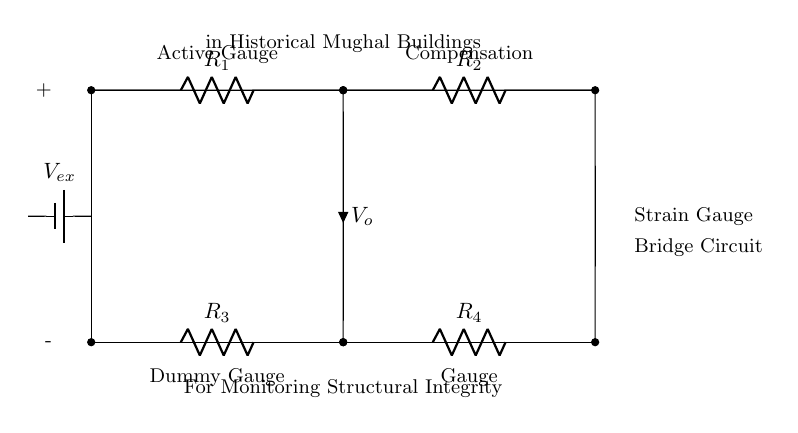What are the resistors labeled as in this circuit? The resistors in this circuit are labeled as R1, R2, R3, and R4, indicating the different positions within the bridge configuration.
Answer: R1, R2, R3, R4 What type of gauges are indicated in the circuit? The circuit includes one active gauge, one dummy gauge, and one compensation gauge. This differentiation helps in measuring strain accurately by compensating for any environmental changes.
Answer: Active gauge, dummy gauge, compensation gauge What is the function of the strain gauge bridge circuit? The function of the strain gauge bridge circuit is to monitor structural integrity, particularly for historical buildings such as Mughal architecture. This helps ensure the safety and preservation of these structures.
Answer: Monitoring structural integrity What is the designation of the output voltage in the circuit? The output voltage is denoted as Vo, which represents the voltage difference measured across the bridge. This voltage can provide information about the strain experienced by the structural component.
Answer: Vo How does the external voltage source connect to the circuit? The external voltage source, labeled as Vex, connects to the circuit by providing the necessary excitation voltage to the strain gauges, facilitating their operation.
Answer: Vex What does the labeling of the components indicate about their roles? The labeling indicates that R1 and R2 are part of the active circuit, while R3 and R4 are intended for compensation, suggesting a balanced configuration for accurate measurement of strain.
Answer: Active and compensation roles What is the importance of using a dummy gauge in the circuit? The dummy gauge is important as it helps eliminate errors in measurement that can occur due to environmental factors or changes, ensuring that the readings from the active gauge accurately reflect structural strain.
Answer: Eliminates measurement errors 